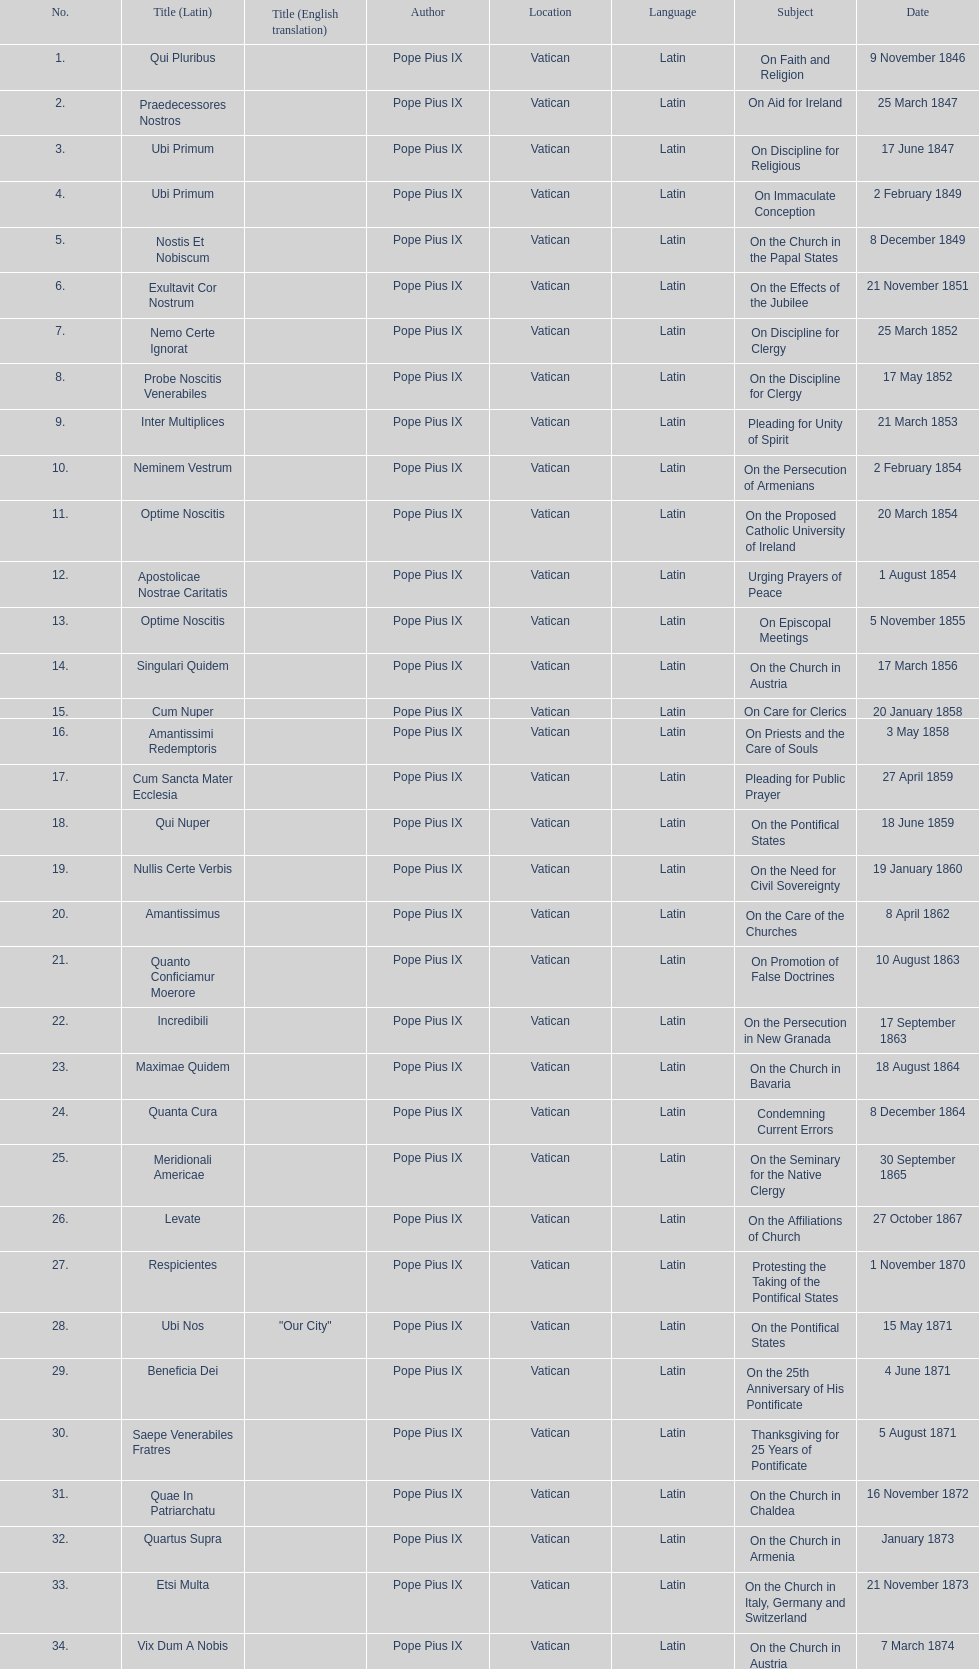Total number of encyclicals on churches . 11. 